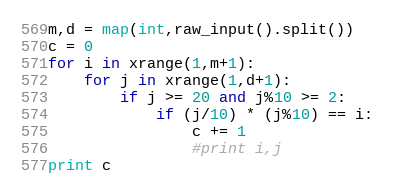Convert code to text. <code><loc_0><loc_0><loc_500><loc_500><_Python_>m,d = map(int,raw_input().split())
c = 0
for i in xrange(1,m+1):
	for j in xrange(1,d+1):
		if j >= 20 and j%10 >= 2:
			if (j/10) * (j%10) == i:
				c += 1
				#print i,j
print c</code> 